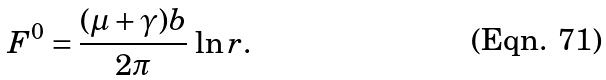<formula> <loc_0><loc_0><loc_500><loc_500>F ^ { 0 } = \frac { ( \mu + \gamma ) b } { 2 \pi } \, \ln r .</formula> 